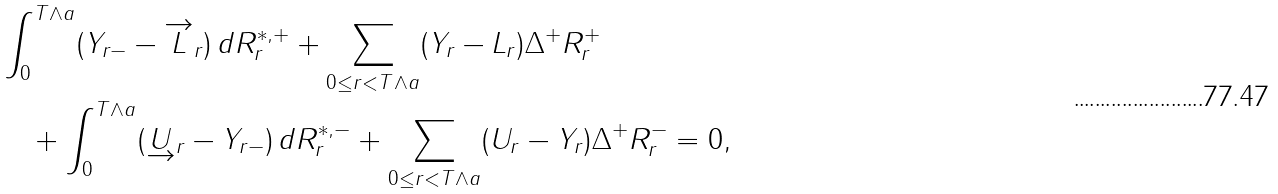Convert formula to latex. <formula><loc_0><loc_0><loc_500><loc_500>& \int ^ { T \wedge a } _ { 0 } ( Y _ { r - } - \overrightarrow { L } _ { r } ) \, d R ^ { * , + } _ { r } + \sum _ { 0 \leq r < T \wedge a } ( Y _ { r } - L _ { r } ) \Delta ^ { + } R ^ { + } _ { r } \\ & \quad + \int ^ { T \wedge a } _ { 0 } ( \underrightarrow { U } _ { r } - Y _ { r - } ) \, d R ^ { * , - } _ { r } + \sum _ { 0 \leq r < T \wedge a } ( U _ { r } - Y _ { r } ) \Delta ^ { + } R ^ { - } _ { r } = 0 ,</formula> 